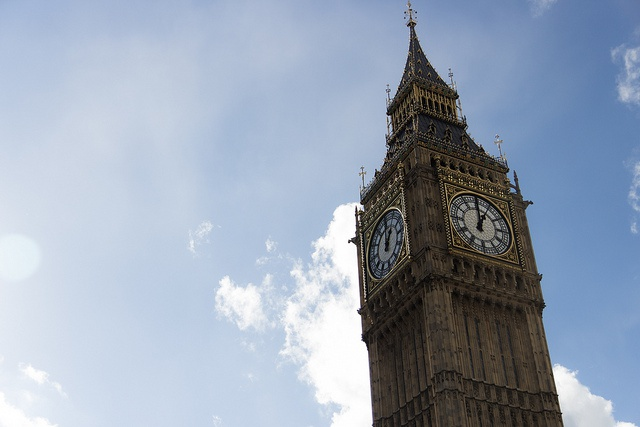Describe the objects in this image and their specific colors. I can see clock in darkgray, black, and gray tones and clock in darkgray, black, and gray tones in this image. 